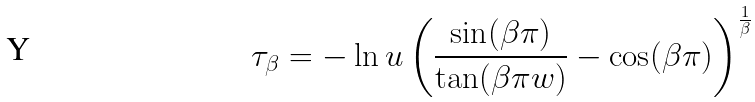Convert formula to latex. <formula><loc_0><loc_0><loc_500><loc_500>\tau _ { \beta } = - \ln u \left ( \frac { \sin ( \beta \pi ) } { \tan ( \beta \pi w ) } - \cos ( \beta \pi ) \right ) ^ { \frac { 1 } { \beta } }</formula> 